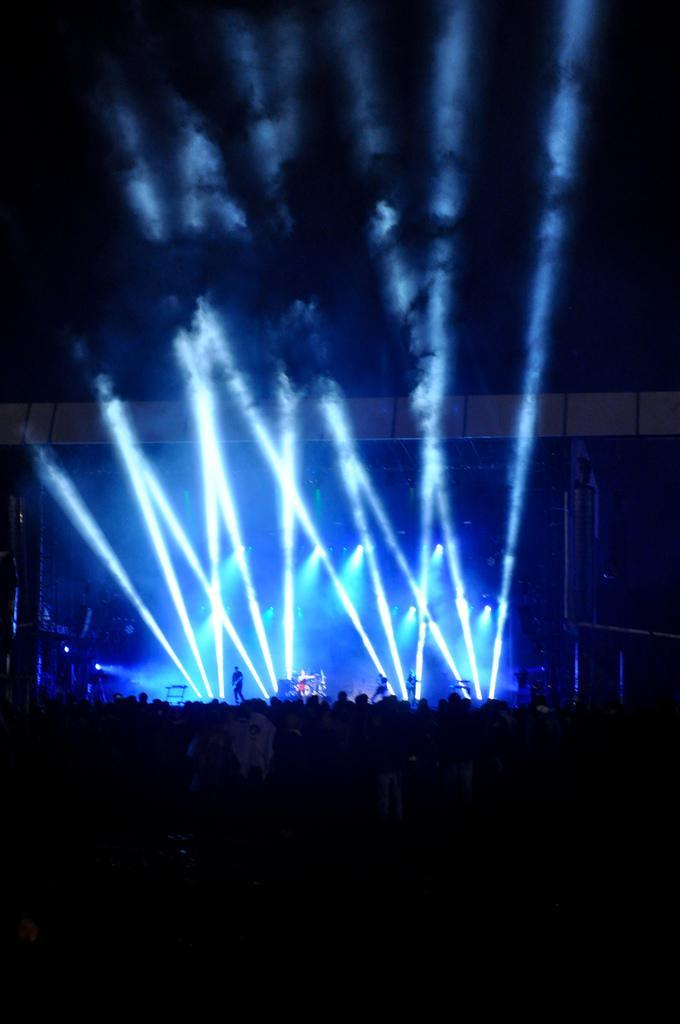How would you summarize this image in a sentence or two? In this image I can see number of persons are standing on the ground, the stage, few persons standing on the stage, few musical instruments and few lights on the stage. In the background I can see the dark sky. 